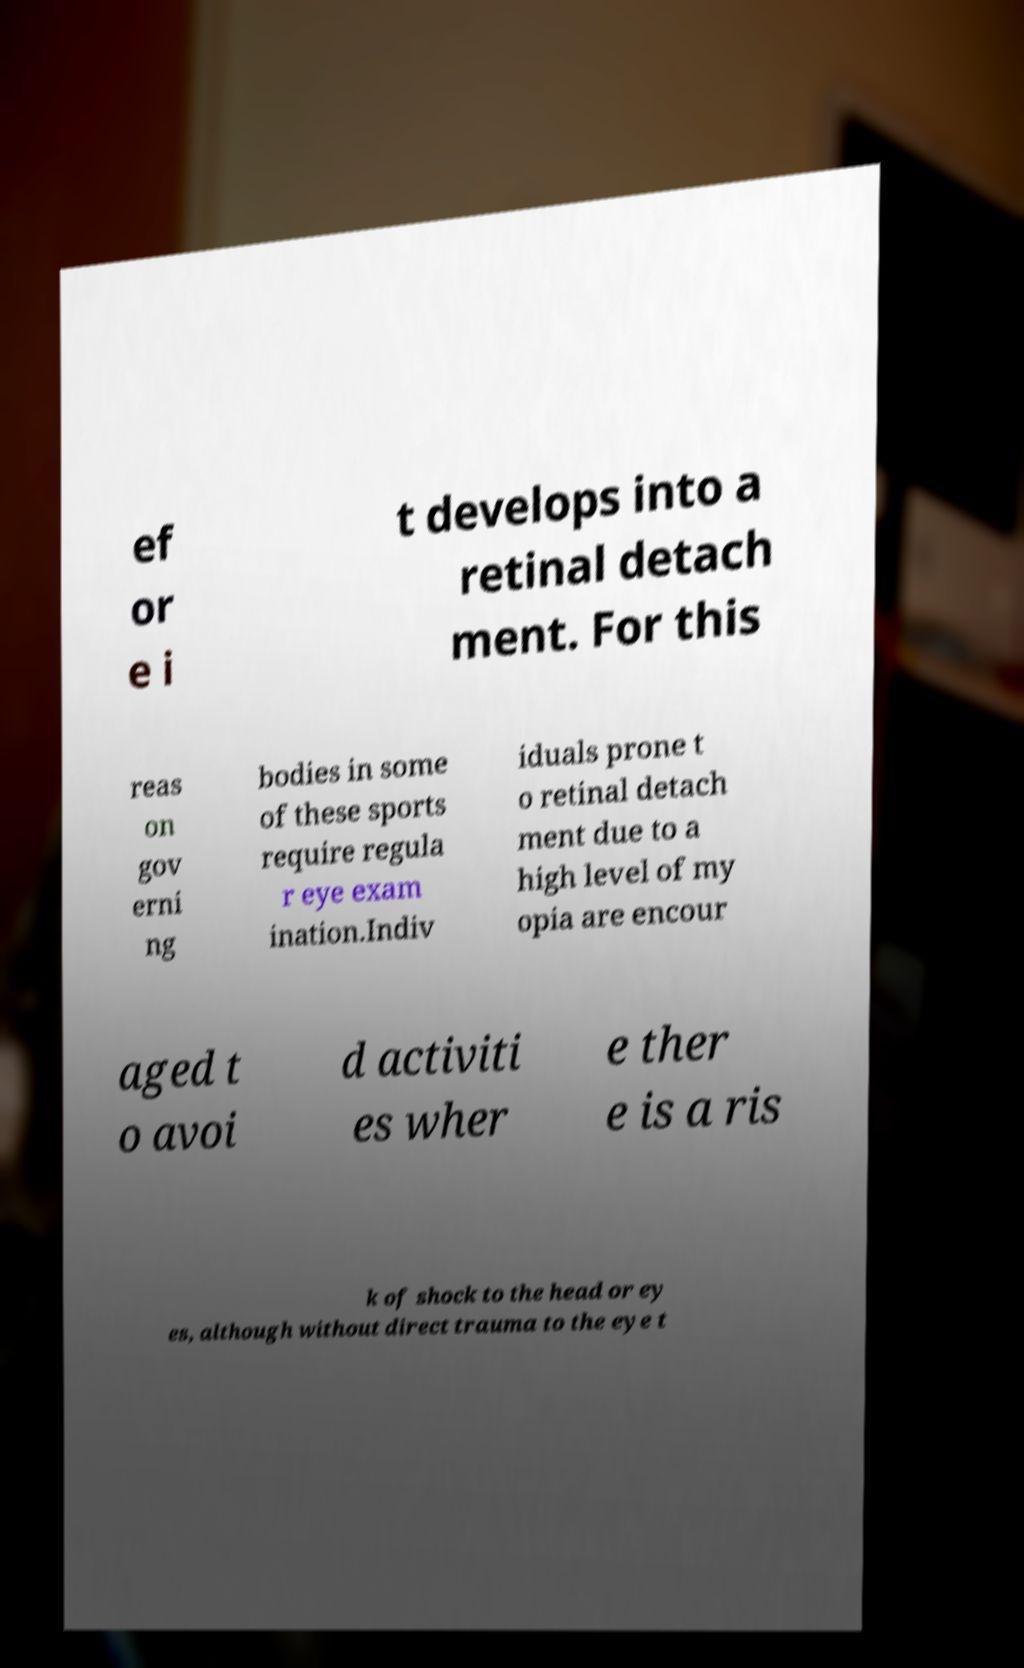Could you extract and type out the text from this image? ef or e i t develops into a retinal detach ment. For this reas on gov erni ng bodies in some of these sports require regula r eye exam ination.Indiv iduals prone t o retinal detach ment due to a high level of my opia are encour aged t o avoi d activiti es wher e ther e is a ris k of shock to the head or ey es, although without direct trauma to the eye t 